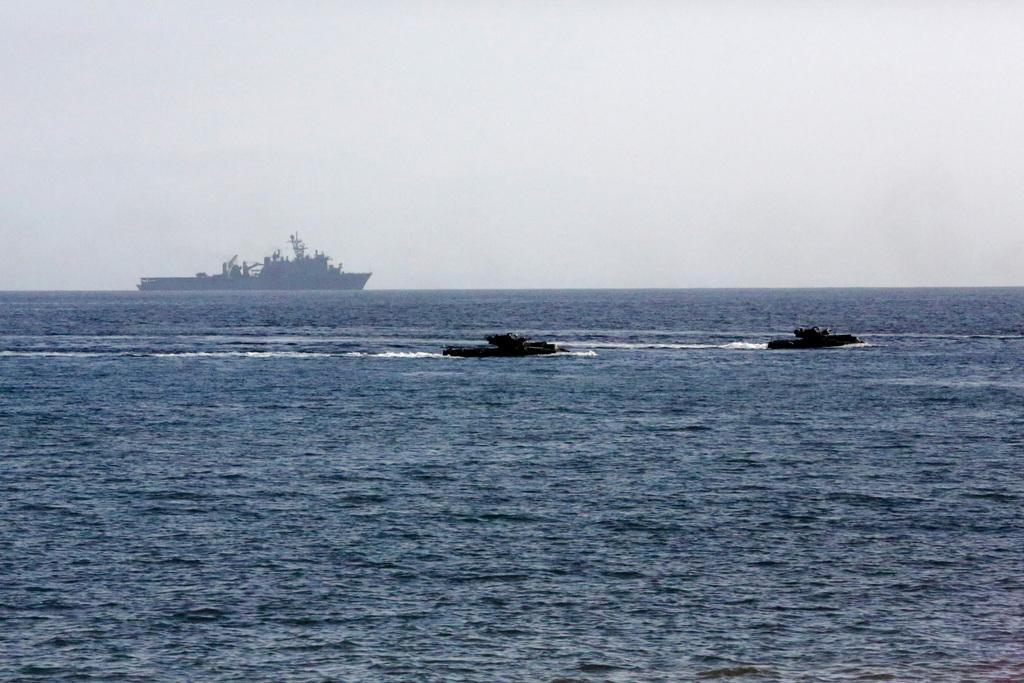Please provide a concise description of this image. In this image I can see the boats on the water. I can see the water in blue color. In the background I can see the sky. 